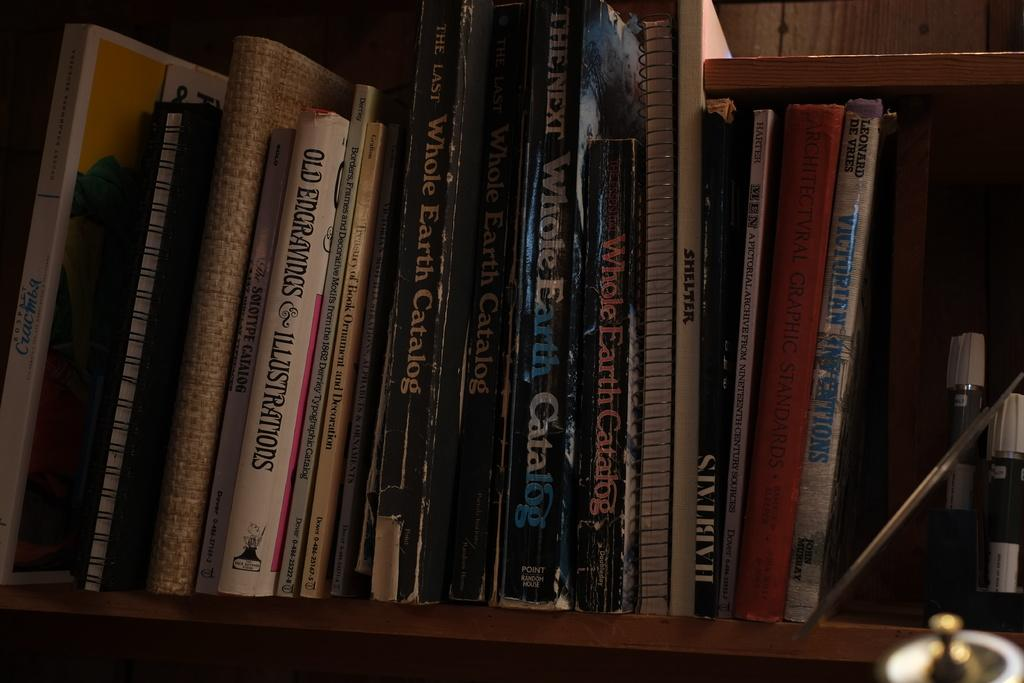<image>
Provide a brief description of the given image. a white book with the word old in the title among other books 